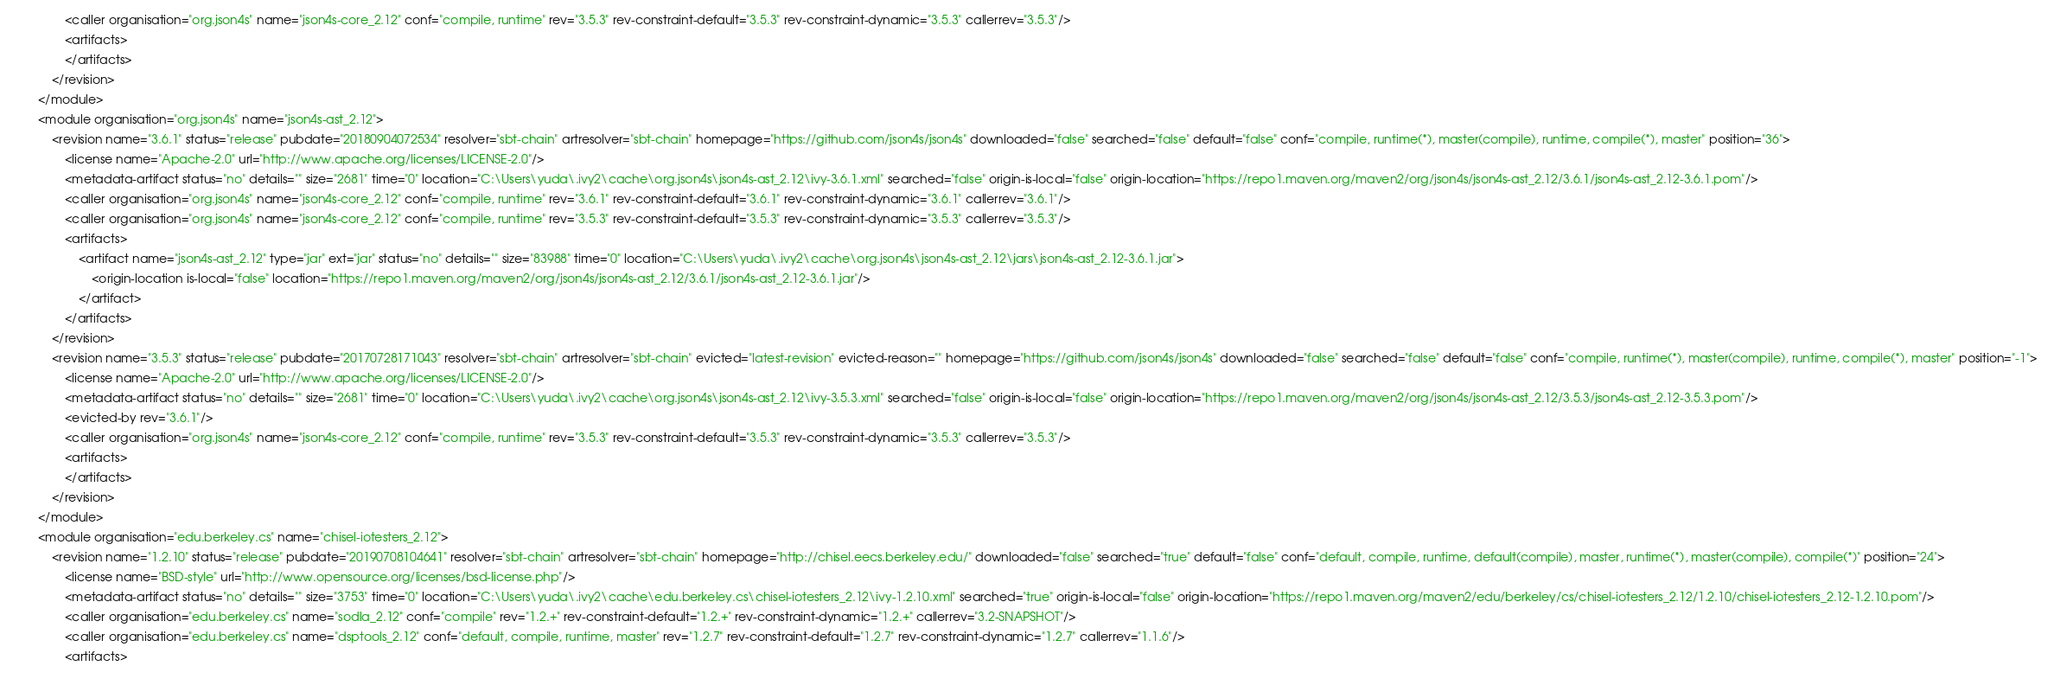Convert code to text. <code><loc_0><loc_0><loc_500><loc_500><_XML_>				<caller organisation="org.json4s" name="json4s-core_2.12" conf="compile, runtime" rev="3.5.3" rev-constraint-default="3.5.3" rev-constraint-dynamic="3.5.3" callerrev="3.5.3"/>
				<artifacts>
				</artifacts>
			</revision>
		</module>
		<module organisation="org.json4s" name="json4s-ast_2.12">
			<revision name="3.6.1" status="release" pubdate="20180904072534" resolver="sbt-chain" artresolver="sbt-chain" homepage="https://github.com/json4s/json4s" downloaded="false" searched="false" default="false" conf="compile, runtime(*), master(compile), runtime, compile(*), master" position="36">
				<license name="Apache-2.0" url="http://www.apache.org/licenses/LICENSE-2.0"/>
				<metadata-artifact status="no" details="" size="2681" time="0" location="C:\Users\yuda\.ivy2\cache\org.json4s\json4s-ast_2.12\ivy-3.6.1.xml" searched="false" origin-is-local="false" origin-location="https://repo1.maven.org/maven2/org/json4s/json4s-ast_2.12/3.6.1/json4s-ast_2.12-3.6.1.pom"/>
				<caller organisation="org.json4s" name="json4s-core_2.12" conf="compile, runtime" rev="3.6.1" rev-constraint-default="3.6.1" rev-constraint-dynamic="3.6.1" callerrev="3.6.1"/>
				<caller organisation="org.json4s" name="json4s-core_2.12" conf="compile, runtime" rev="3.5.3" rev-constraint-default="3.5.3" rev-constraint-dynamic="3.5.3" callerrev="3.5.3"/>
				<artifacts>
					<artifact name="json4s-ast_2.12" type="jar" ext="jar" status="no" details="" size="83988" time="0" location="C:\Users\yuda\.ivy2\cache\org.json4s\json4s-ast_2.12\jars\json4s-ast_2.12-3.6.1.jar">
						<origin-location is-local="false" location="https://repo1.maven.org/maven2/org/json4s/json4s-ast_2.12/3.6.1/json4s-ast_2.12-3.6.1.jar"/>
					</artifact>
				</artifacts>
			</revision>
			<revision name="3.5.3" status="release" pubdate="20170728171043" resolver="sbt-chain" artresolver="sbt-chain" evicted="latest-revision" evicted-reason="" homepage="https://github.com/json4s/json4s" downloaded="false" searched="false" default="false" conf="compile, runtime(*), master(compile), runtime, compile(*), master" position="-1">
				<license name="Apache-2.0" url="http://www.apache.org/licenses/LICENSE-2.0"/>
				<metadata-artifact status="no" details="" size="2681" time="0" location="C:\Users\yuda\.ivy2\cache\org.json4s\json4s-ast_2.12\ivy-3.5.3.xml" searched="false" origin-is-local="false" origin-location="https://repo1.maven.org/maven2/org/json4s/json4s-ast_2.12/3.5.3/json4s-ast_2.12-3.5.3.pom"/>
				<evicted-by rev="3.6.1"/>
				<caller organisation="org.json4s" name="json4s-core_2.12" conf="compile, runtime" rev="3.5.3" rev-constraint-default="3.5.3" rev-constraint-dynamic="3.5.3" callerrev="3.5.3"/>
				<artifacts>
				</artifacts>
			</revision>
		</module>
		<module organisation="edu.berkeley.cs" name="chisel-iotesters_2.12">
			<revision name="1.2.10" status="release" pubdate="20190708104641" resolver="sbt-chain" artresolver="sbt-chain" homepage="http://chisel.eecs.berkeley.edu/" downloaded="false" searched="true" default="false" conf="default, compile, runtime, default(compile), master, runtime(*), master(compile), compile(*)" position="24">
				<license name="BSD-style" url="http://www.opensource.org/licenses/bsd-license.php"/>
				<metadata-artifact status="no" details="" size="3753" time="0" location="C:\Users\yuda\.ivy2\cache\edu.berkeley.cs\chisel-iotesters_2.12\ivy-1.2.10.xml" searched="true" origin-is-local="false" origin-location="https://repo1.maven.org/maven2/edu/berkeley/cs/chisel-iotesters_2.12/1.2.10/chisel-iotesters_2.12-1.2.10.pom"/>
				<caller organisation="edu.berkeley.cs" name="sodla_2.12" conf="compile" rev="1.2.+" rev-constraint-default="1.2.+" rev-constraint-dynamic="1.2.+" callerrev="3.2-SNAPSHOT"/>
				<caller organisation="edu.berkeley.cs" name="dsptools_2.12" conf="default, compile, runtime, master" rev="1.2.7" rev-constraint-default="1.2.7" rev-constraint-dynamic="1.2.7" callerrev="1.1.6"/>
				<artifacts></code> 